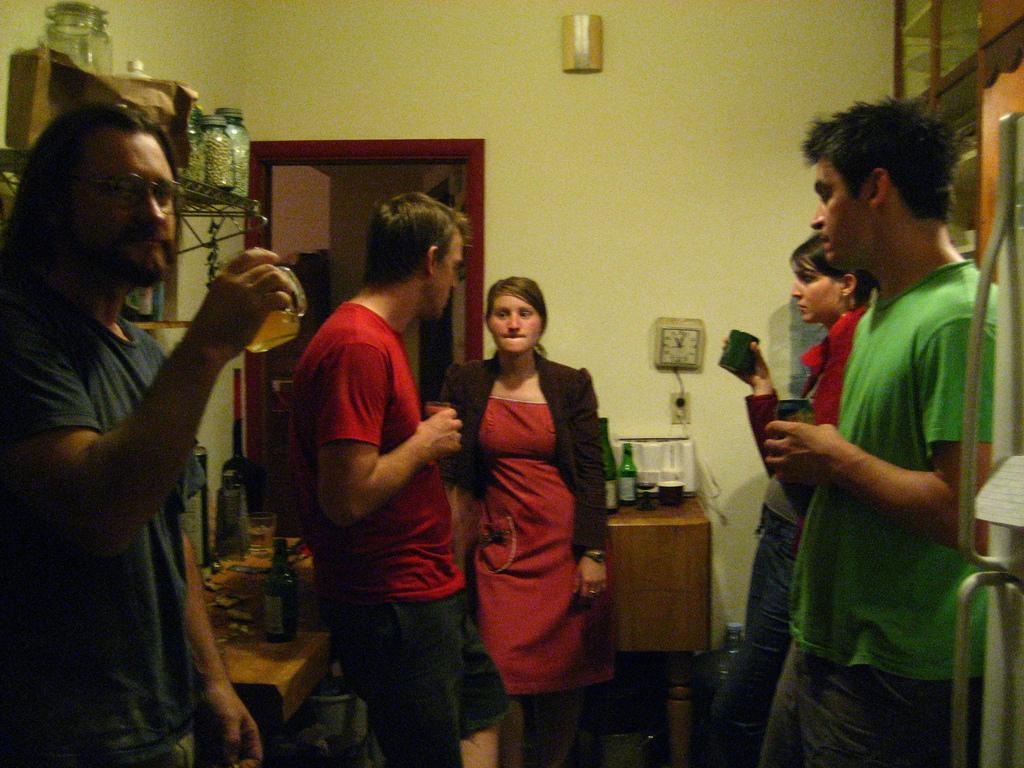How would you summarize this image in a sentence or two? In this image, we can see a group of people wearing clothes and standing in front of the wall. There is a door in the middle of the image. There are tables contains some bottles. There is a wall shelf in the top left of the image contains some jars. 